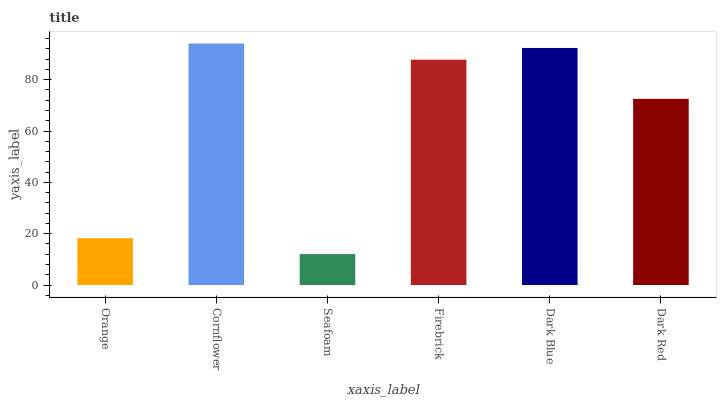Is Cornflower the minimum?
Answer yes or no. No. Is Seafoam the maximum?
Answer yes or no. No. Is Cornflower greater than Seafoam?
Answer yes or no. Yes. Is Seafoam less than Cornflower?
Answer yes or no. Yes. Is Seafoam greater than Cornflower?
Answer yes or no. No. Is Cornflower less than Seafoam?
Answer yes or no. No. Is Firebrick the high median?
Answer yes or no. Yes. Is Dark Red the low median?
Answer yes or no. Yes. Is Seafoam the high median?
Answer yes or no. No. Is Dark Blue the low median?
Answer yes or no. No. 